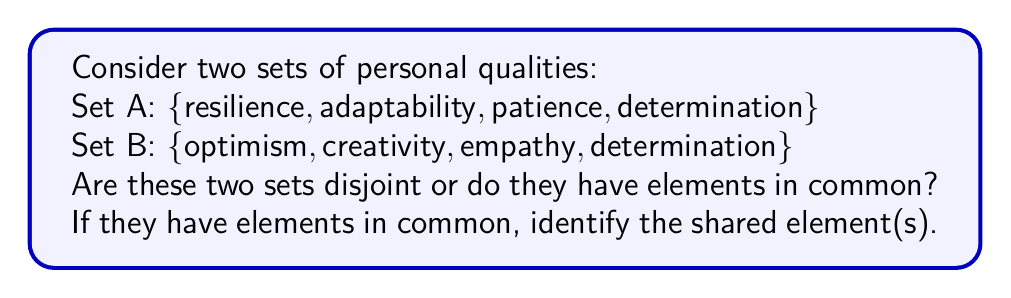Could you help me with this problem? To determine if two sets are disjoint or have elements in common, we need to compare the elements of both sets:

1. First, let's define our sets:
   Set A = {resilience, adaptability, patience, determination}
   Set B = {optimism, creativity, empathy, determination}

2. We need to check if there are any elements that appear in both sets.

3. Let's go through each element of Set A and see if it appears in Set B:
   - resilience: not in Set B
   - adaptability: not in Set B
   - patience: not in Set B
   - determination: also in Set B

4. We've found that "determination" appears in both Set A and Set B.

5. The intersection of two sets is defined as the set of elements that are common to both sets. We can write this mathematically as:

   $A \cap B = \{determination\}$

6. Since the intersection is not empty ($A \cap B \neq \emptyset$), we can conclude that the sets are not disjoint.

7. Two sets are considered disjoint if and only if their intersection is empty. In this case, the intersection is not empty, so the sets are not disjoint.
Answer: The two sets are not disjoint. They have one element in common: determination. 